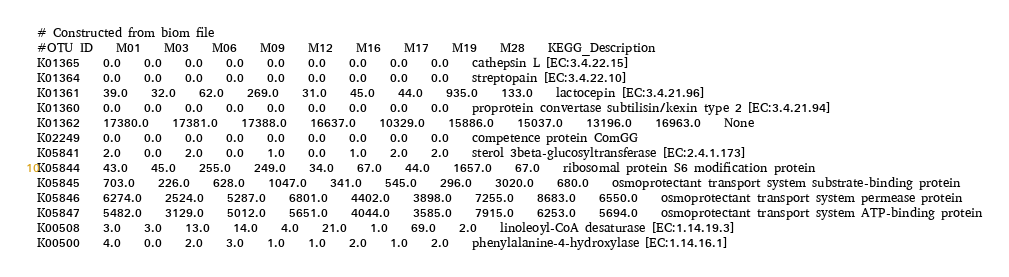<code> <loc_0><loc_0><loc_500><loc_500><_SQL_># Constructed from biom file
#OTU ID	M01	M03	M06	M09	M12	M16	M17	M19	M28	KEGG_Description
K01365	0.0	0.0	0.0	0.0	0.0	0.0	0.0	0.0	0.0	cathepsin L [EC:3.4.22.15]
K01364	0.0	0.0	0.0	0.0	0.0	0.0	0.0	0.0	0.0	streptopain [EC:3.4.22.10]
K01361	39.0	32.0	62.0	269.0	31.0	45.0	44.0	935.0	133.0	lactocepin [EC:3.4.21.96]
K01360	0.0	0.0	0.0	0.0	0.0	0.0	0.0	0.0	0.0	proprotein convertase subtilisin/kexin type 2 [EC:3.4.21.94]
K01362	17380.0	17381.0	17388.0	16637.0	10329.0	15886.0	15037.0	13196.0	16963.0	None
K02249	0.0	0.0	0.0	0.0	0.0	0.0	0.0	0.0	0.0	competence protein ComGG
K05841	2.0	0.0	2.0	0.0	1.0	0.0	1.0	2.0	2.0	sterol 3beta-glucosyltransferase [EC:2.4.1.173]
K05844	43.0	45.0	255.0	249.0	34.0	67.0	44.0	1657.0	67.0	ribosomal protein S6 modification protein
K05845	703.0	226.0	628.0	1047.0	341.0	545.0	296.0	3020.0	680.0	osmoprotectant transport system substrate-binding protein
K05846	6274.0	2524.0	5287.0	6801.0	4402.0	3898.0	7255.0	8683.0	6550.0	osmoprotectant transport system permease protein
K05847	5482.0	3129.0	5012.0	5651.0	4044.0	3585.0	7915.0	6253.0	5694.0	osmoprotectant transport system ATP-binding protein
K00508	3.0	3.0	13.0	14.0	4.0	21.0	1.0	69.0	2.0	linoleoyl-CoA desaturase [EC:1.14.19.3]
K00500	4.0	0.0	2.0	3.0	1.0	1.0	2.0	1.0	2.0	phenylalanine-4-hydroxylase [EC:1.14.16.1]</code> 